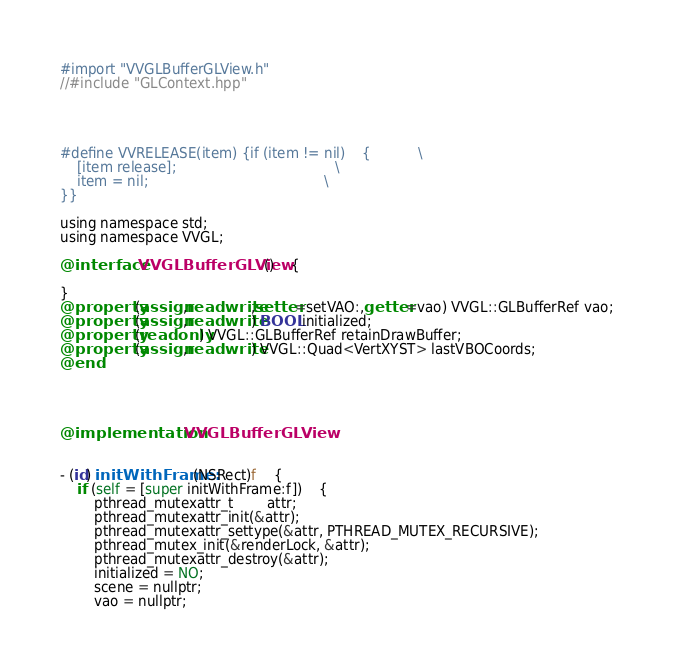Convert code to text. <code><loc_0><loc_0><loc_500><loc_500><_ObjectiveC_>#import "VVGLBufferGLView.h"
//#include "GLContext.hpp"




#define VVRELEASE(item) {if (item != nil)	{			\
	[item release];										\
	item = nil;											\
}}

using namespace std;
using namespace VVGL;

@interface VVGLBufferGLView()	{
	
}
@property (assign,readwrite,setter=setVAO:,getter=vao) VVGL::GLBufferRef vao;
@property (assign,readwrite) BOOL initialized;
@property (readonly) VVGL::GLBufferRef retainDrawBuffer;
@property (assign,readwrite) VVGL::Quad<VertXYST> lastVBOCoords;
@end




@implementation VVGLBufferGLView


- (id) initWithFrame:(NSRect)f	{
	if (self = [super initWithFrame:f])	{
		pthread_mutexattr_t		attr;
		pthread_mutexattr_init(&attr);
		pthread_mutexattr_settype(&attr, PTHREAD_MUTEX_RECURSIVE);
		pthread_mutex_init(&renderLock, &attr);
		pthread_mutexattr_destroy(&attr);
		initialized = NO;
		scene = nullptr;
		vao = nullptr;</code> 